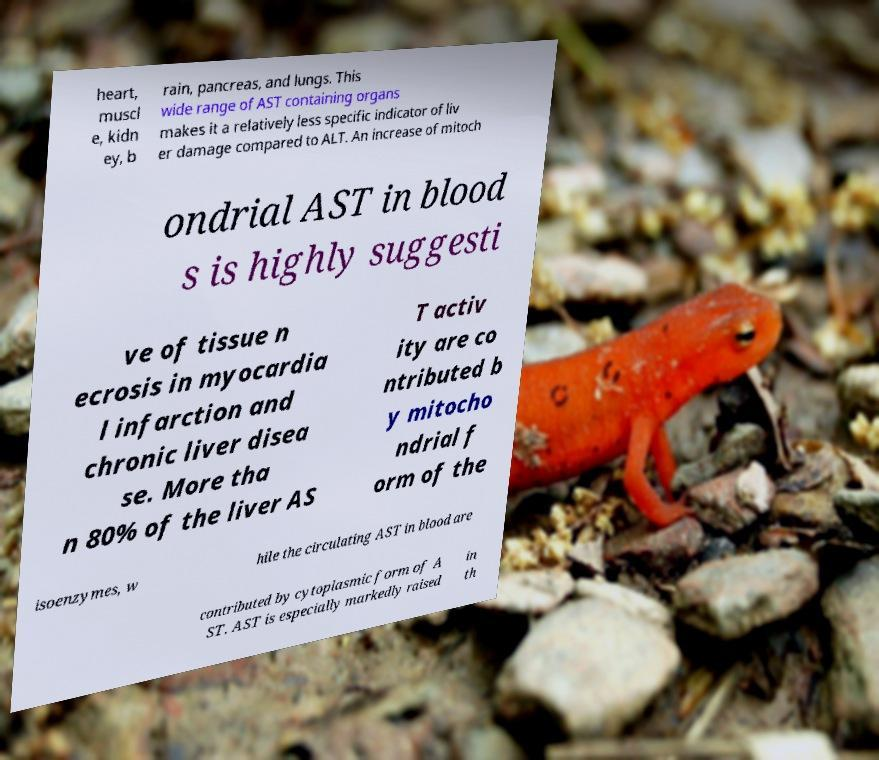Can you read and provide the text displayed in the image?This photo seems to have some interesting text. Can you extract and type it out for me? heart, muscl e, kidn ey, b rain, pancreas, and lungs. This wide range of AST containing organs makes it a relatively less specific indicator of liv er damage compared to ALT. An increase of mitoch ondrial AST in blood s is highly suggesti ve of tissue n ecrosis in myocardia l infarction and chronic liver disea se. More tha n 80% of the liver AS T activ ity are co ntributed b y mitocho ndrial f orm of the isoenzymes, w hile the circulating AST in blood are contributed by cytoplasmic form of A ST. AST is especially markedly raised in th 